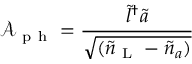<formula> <loc_0><loc_0><loc_500><loc_500>\mathcal { A } _ { p h } = \frac { \tilde { l } ^ { \dagger } \tilde { a } } { \sqrt { ( \tilde { n } _ { L } - \tilde { n } _ { a } ) } }</formula> 